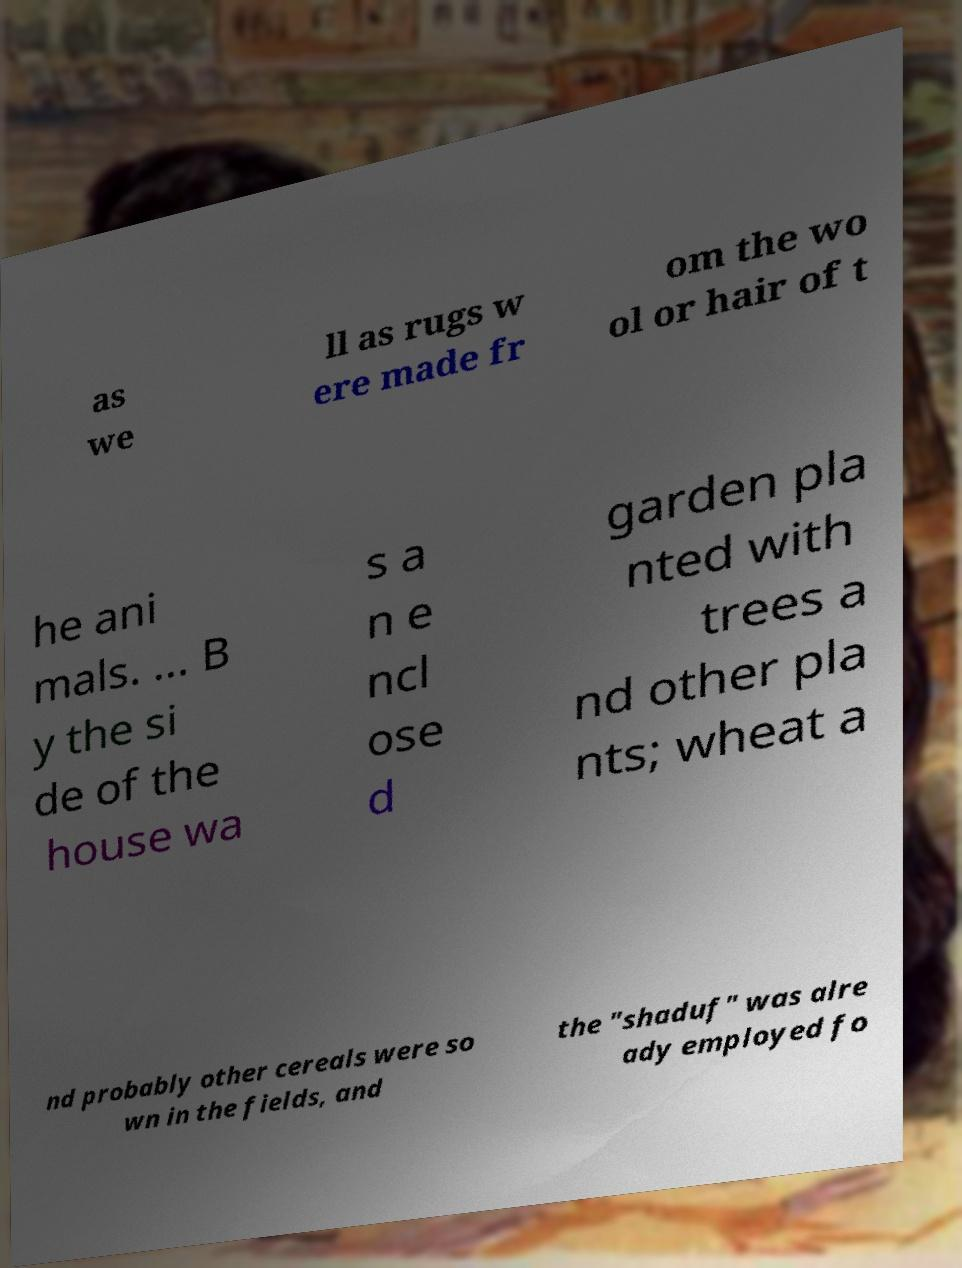Can you accurately transcribe the text from the provided image for me? as we ll as rugs w ere made fr om the wo ol or hair of t he ani mals. ... B y the si de of the house wa s a n e ncl ose d garden pla nted with trees a nd other pla nts; wheat a nd probably other cereals were so wn in the fields, and the "shaduf" was alre ady employed fo 